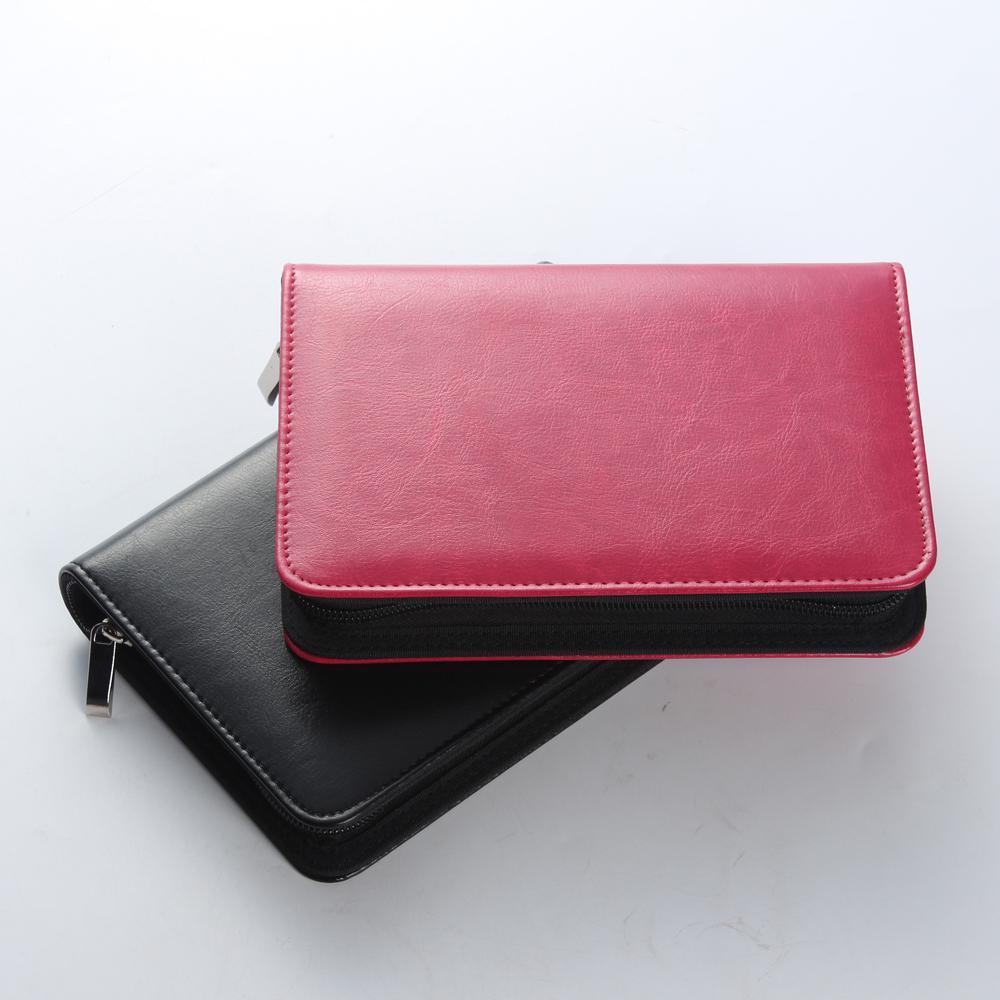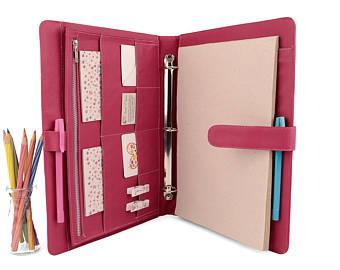The first image is the image on the left, the second image is the image on the right. Assess this claim about the two images: "In total, four binders are shown.". Correct or not? Answer yes or no. No. 